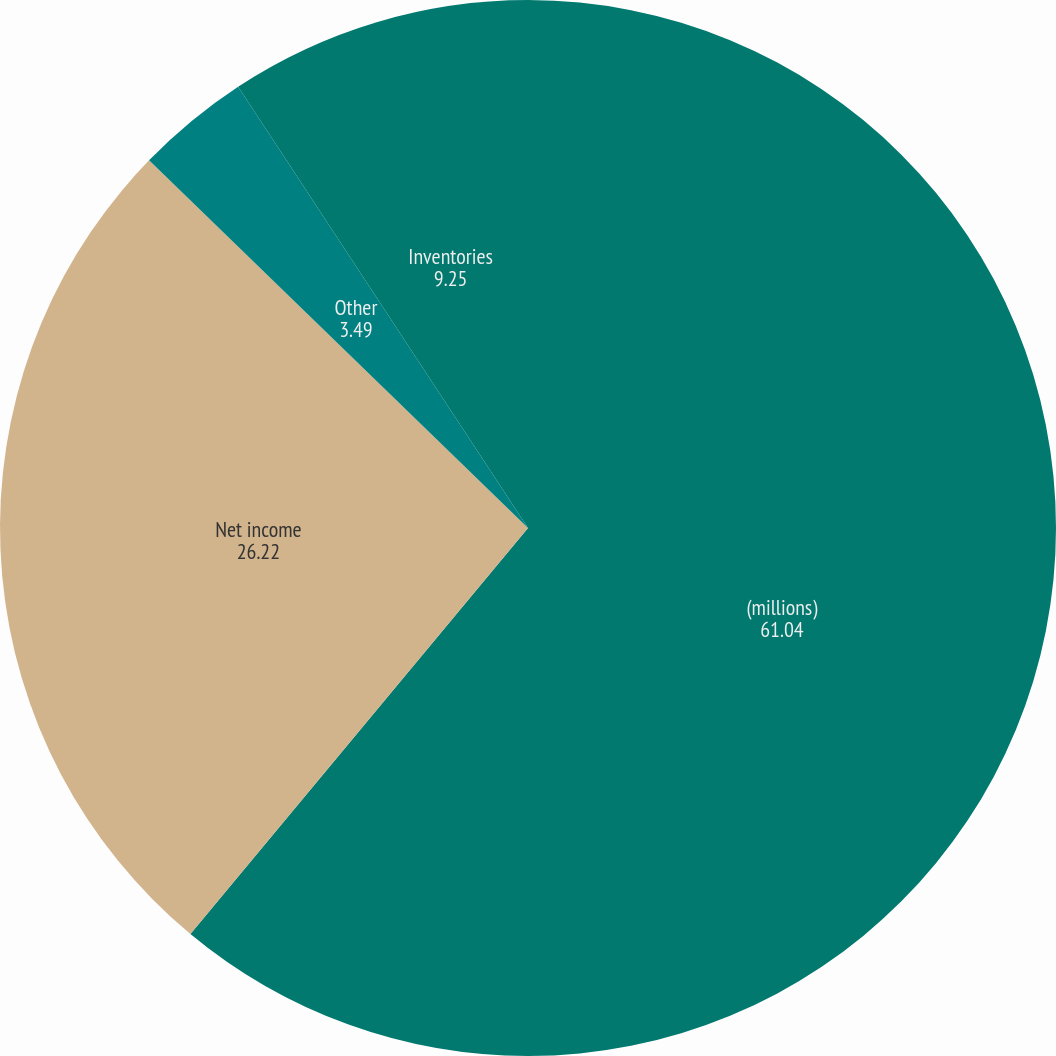Convert chart to OTSL. <chart><loc_0><loc_0><loc_500><loc_500><pie_chart><fcel>(millions)<fcel>Net income<fcel>Other<fcel>Inventories<nl><fcel>61.04%<fcel>26.22%<fcel>3.49%<fcel>9.25%<nl></chart> 